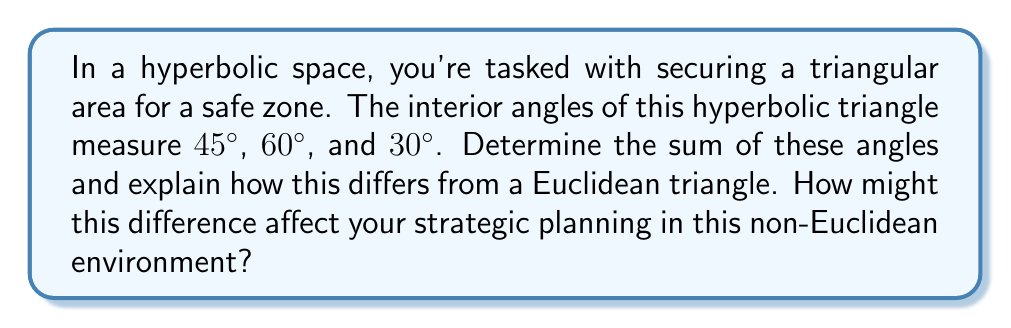Show me your answer to this math problem. Let's approach this step-by-step:

1) First, let's recall the formula for the sum of angles in a hyperbolic triangle:

   $$\alpha + \beta + \gamma = \pi - A$$

   Where $\alpha$, $\beta$, and $\gamma$ are the interior angles, and $A$ is the area of the triangle in the hyperbolic plane.

2) In our case, we have:
   $$45° + 60° + 30° = 135°$$

3) Converting to radians:
   $$135° \times \frac{\pi}{180°} = \frac{3\pi}{4} \approx 2.356 \text{ radians}$$

4) In a Euclidean plane, the sum would always be $\pi$ radians or 180°. Here, we see that:

   $$\frac{3\pi}{4} < \pi$$

5) The difference $\pi - \frac{3\pi}{4} = \frac{\pi}{4}$ represents the area $A$ of the triangle in the hyperbolic plane.

6) This means that in hyperbolic geometry, the sum of angles in a triangle is always less than 180°, and the "missing" angle sum corresponds to the area of the triangle.

7) In strategic planning, this has several implications:
   - Distances and areas behave differently than in Euclidean space.
   - Line of sight and coverage areas may be affected.
   - Navigation and positioning strategies need to account for these differences.
Answer: $\frac{3\pi}{4}$ radians or 135° 